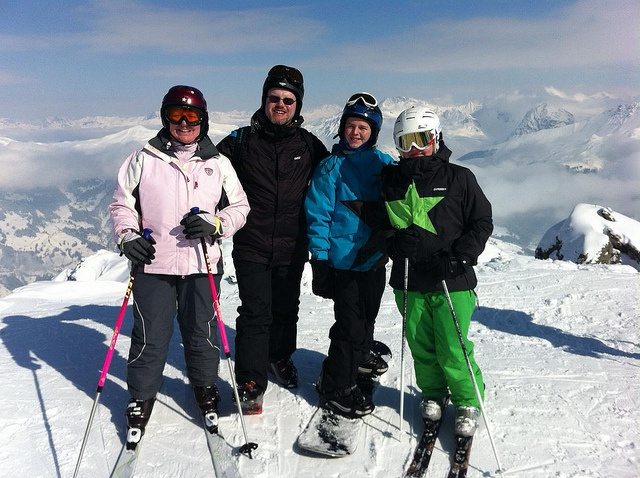Describe the objects in this image and their specific colors. I can see people in gray, black, lavender, and darkgray tones, people in gray, black, darkgreen, ivory, and green tones, people in gray, black, lightgray, and brown tones, people in gray, black, navy, teal, and blue tones, and snowboard in gray, darkgray, black, and lightgray tones in this image. 